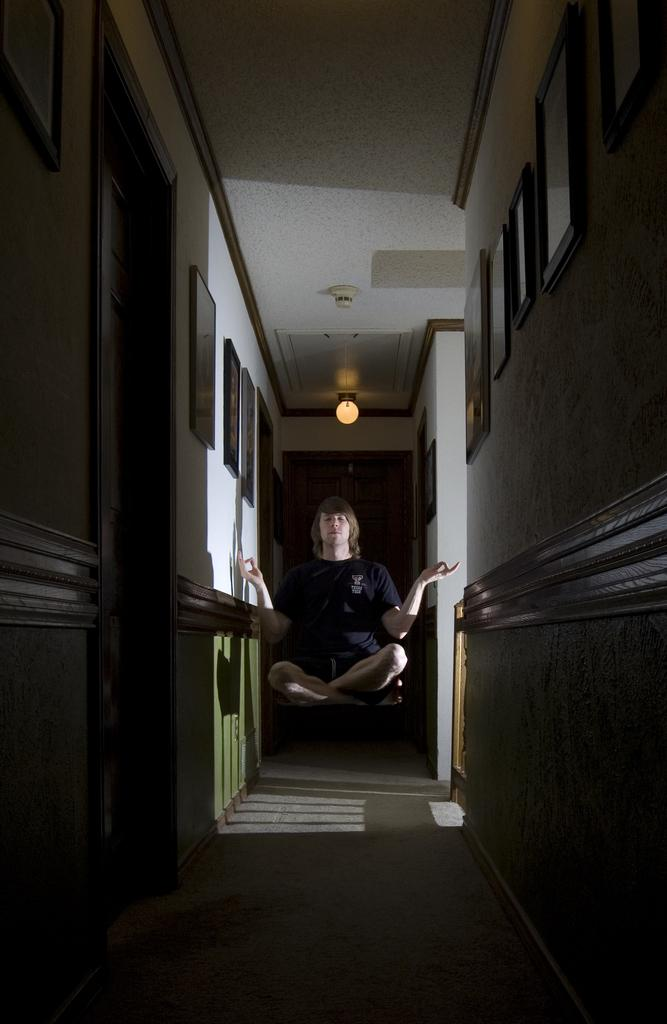What is the main subject in the middle of the image? There is a person in the middle of the image. What can be seen on both sides of the person? There are walls on both the right and left sides of the image. What is hanging on the walls? There are photo frames on the walls. What can be seen in the background of the image? There is a light visible in the background of the image. What type of button is being used by the person in the image? There is no button visible in the image, and the person's actions are not described. What is the person doing with their tongue in the image? There is no mention of the person's tongue or any related actions in the image. 